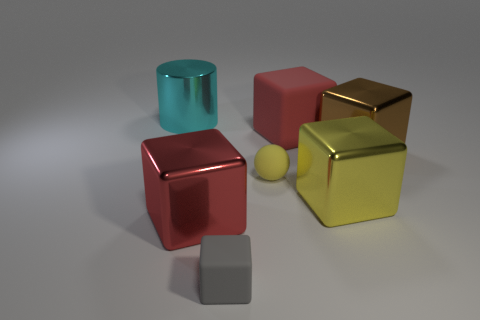What is the size of the metallic block that is the same color as the sphere?
Your answer should be very brief. Large. Are there an equal number of tiny gray matte objects in front of the small matte cube and big yellow blocks that are in front of the red metal cube?
Your answer should be very brief. Yes. What is the color of the matte cube that is behind the big yellow metal block?
Your answer should be very brief. Red. Do the shiny cylinder and the small rubber thing in front of the rubber sphere have the same color?
Provide a succinct answer. No. Is the number of small green matte balls less than the number of gray matte cubes?
Your answer should be very brief. Yes. There is a small thing to the right of the gray rubber cube; is it the same color as the metallic cylinder?
Offer a terse response. No. How many yellow objects are the same size as the cyan cylinder?
Make the answer very short. 1. Are there any large rubber things of the same color as the cylinder?
Your answer should be very brief. No. Is the big cyan cylinder made of the same material as the gray cube?
Keep it short and to the point. No. What number of large brown things have the same shape as the red shiny object?
Provide a succinct answer. 1. 